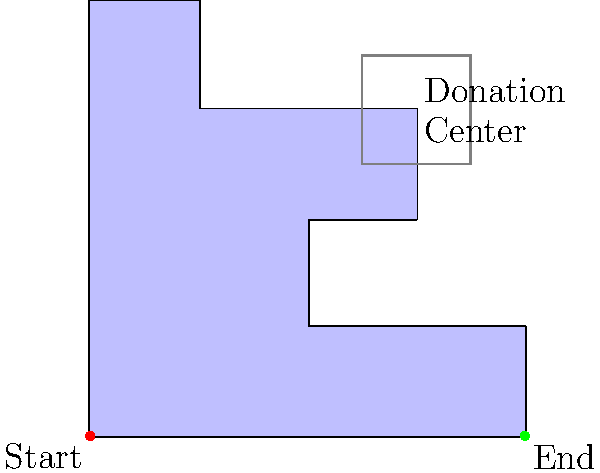In this maze representing a charity event in Port of Spain, you start at the red dot and need to reach the green dot. The gray square represents a donation center. What is the minimum number of 90-degree turns required to reach the end while passing through the donation center? Let's navigate the maze step-by-step:

1. Start at the red dot (0,0).
2. Move upwards to (0,4). This is our first turn.
3. Turn right and move to (1,4). Second turn.
4. Turn down to (1,3). Third turn.
5. Turn right to (3,3), entering the donation center. Fourth turn.
6. Exit the donation center, turning down to (3,2). Fifth turn.
7. Turn left to (2,2). Sixth turn.
8. Turn down to (2,1). Seventh turn.
9. Turn right to (4,1). Eighth turn.
10. Finally, turn down to reach the end at (4,0). Ninth turn.

In total, we made 9 90-degree turns while navigating through the maze and passing through the donation center.
Answer: 9 turns 